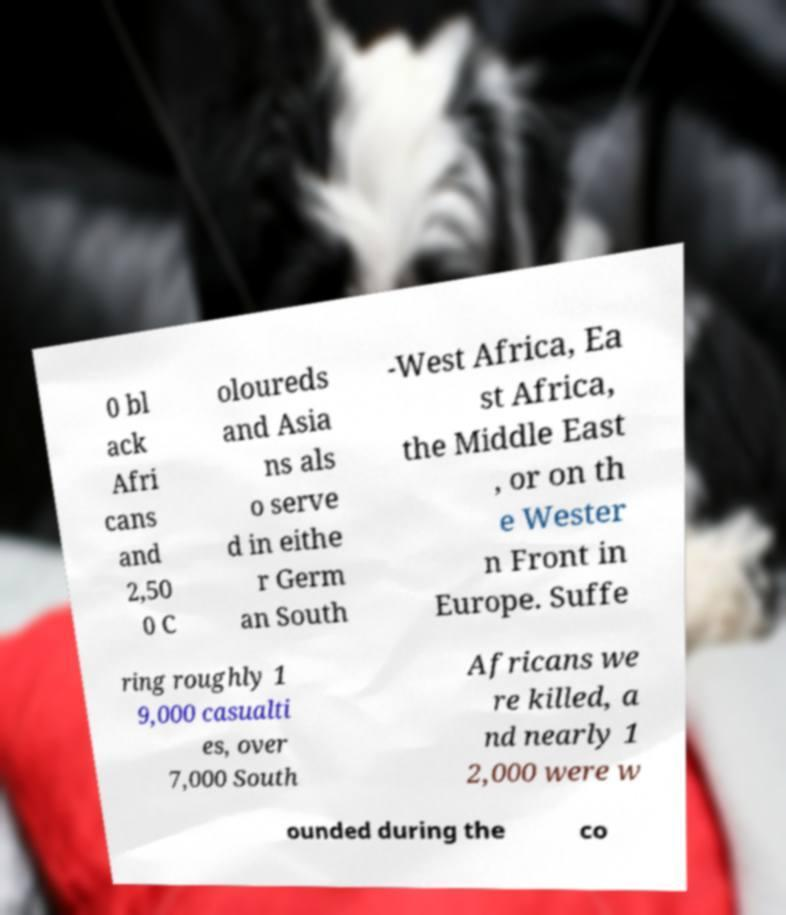Please read and relay the text visible in this image. What does it say? 0 bl ack Afri cans and 2,50 0 C oloureds and Asia ns als o serve d in eithe r Germ an South -West Africa, Ea st Africa, the Middle East , or on th e Wester n Front in Europe. Suffe ring roughly 1 9,000 casualti es, over 7,000 South Africans we re killed, a nd nearly 1 2,000 were w ounded during the co 